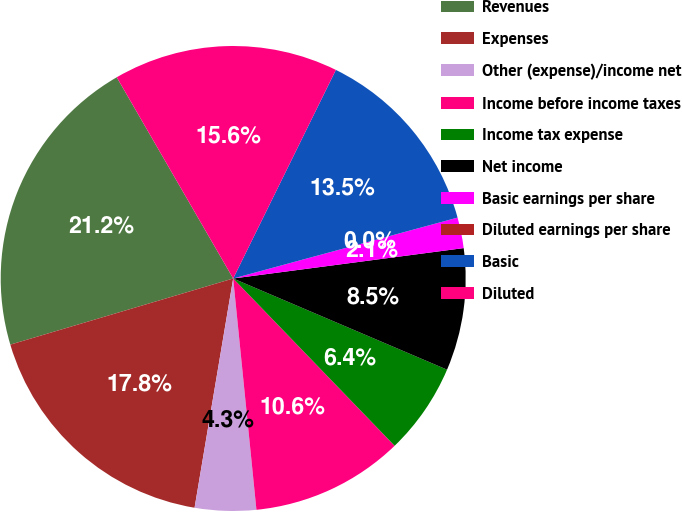<chart> <loc_0><loc_0><loc_500><loc_500><pie_chart><fcel>Revenues<fcel>Expenses<fcel>Other (expense)/income net<fcel>Income before income taxes<fcel>Income tax expense<fcel>Net income<fcel>Basic earnings per share<fcel>Diluted earnings per share<fcel>Basic<fcel>Diluted<nl><fcel>21.24%<fcel>17.75%<fcel>4.25%<fcel>10.62%<fcel>6.37%<fcel>8.5%<fcel>2.13%<fcel>0.0%<fcel>13.5%<fcel>15.63%<nl></chart> 